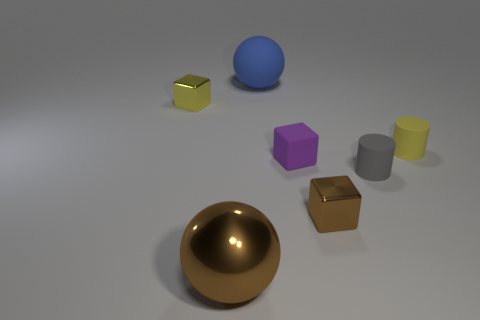Can you tell me the colors of all the objects present in the image? Certainly! In the image, there are objects in gold, blue, purple, grey, yellow, and a light shade of yellow that could be considered off-white. 